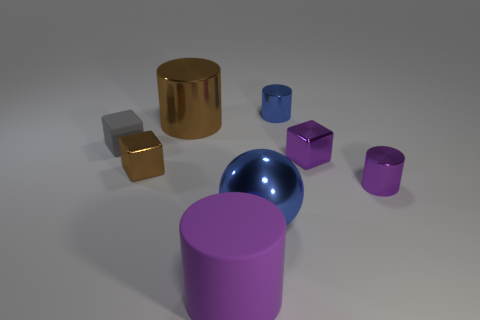Which object appears to be closest to the point of view? From the given perspective, the closest object to the viewer appears to be the small, shiny silver cube that's directly in the center of the frame. Does this object have any special features compared to the others? The small silver cube has a distinctly less reflective surface than some of the other objects, such as the golden cylinder and the blue sphere. 